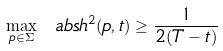<formula> <loc_0><loc_0><loc_500><loc_500>\max _ { p \in \Sigma } \ a b s { h } ^ { 2 } ( p , t ) \geq \frac { 1 } { 2 ( T - t ) }</formula> 